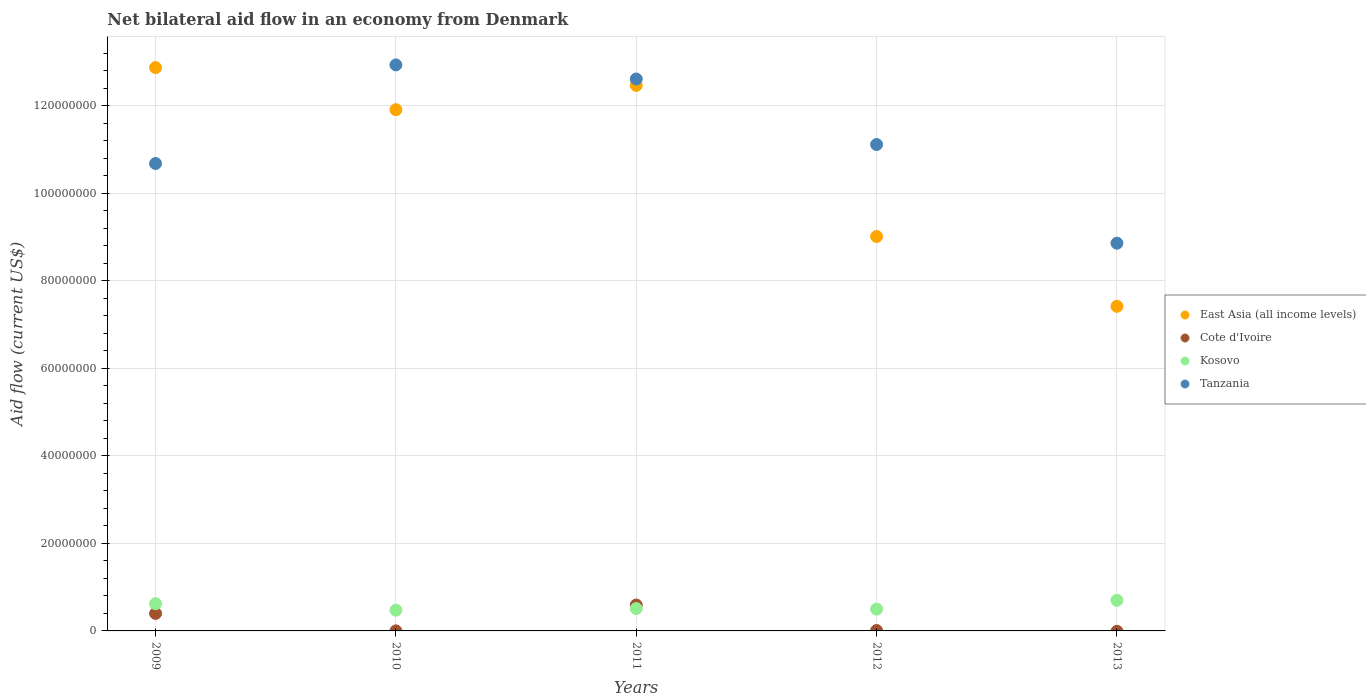Is the number of dotlines equal to the number of legend labels?
Your response must be concise. No. What is the net bilateral aid flow in Tanzania in 2009?
Ensure brevity in your answer.  1.07e+08. Across all years, what is the maximum net bilateral aid flow in East Asia (all income levels)?
Keep it short and to the point. 1.29e+08. Across all years, what is the minimum net bilateral aid flow in Tanzania?
Offer a terse response. 8.86e+07. What is the total net bilateral aid flow in Kosovo in the graph?
Provide a short and direct response. 2.81e+07. What is the difference between the net bilateral aid flow in Kosovo in 2010 and that in 2013?
Provide a succinct answer. -2.26e+06. What is the difference between the net bilateral aid flow in East Asia (all income levels) in 2011 and the net bilateral aid flow in Kosovo in 2010?
Keep it short and to the point. 1.20e+08. What is the average net bilateral aid flow in Kosovo per year?
Give a very brief answer. 5.61e+06. In the year 2010, what is the difference between the net bilateral aid flow in Kosovo and net bilateral aid flow in Tanzania?
Provide a succinct answer. -1.25e+08. In how many years, is the net bilateral aid flow in East Asia (all income levels) greater than 32000000 US$?
Your answer should be very brief. 5. What is the ratio of the net bilateral aid flow in Tanzania in 2010 to that in 2013?
Offer a terse response. 1.46. What is the difference between the highest and the second highest net bilateral aid flow in East Asia (all income levels)?
Ensure brevity in your answer.  4.06e+06. What is the difference between the highest and the lowest net bilateral aid flow in East Asia (all income levels)?
Offer a terse response. 5.46e+07. In how many years, is the net bilateral aid flow in East Asia (all income levels) greater than the average net bilateral aid flow in East Asia (all income levels) taken over all years?
Offer a terse response. 3. Is the sum of the net bilateral aid flow in Kosovo in 2011 and 2013 greater than the maximum net bilateral aid flow in Cote d'Ivoire across all years?
Your answer should be compact. Yes. Is it the case that in every year, the sum of the net bilateral aid flow in Kosovo and net bilateral aid flow in Tanzania  is greater than the net bilateral aid flow in East Asia (all income levels)?
Give a very brief answer. No. Is the net bilateral aid flow in Kosovo strictly less than the net bilateral aid flow in Cote d'Ivoire over the years?
Keep it short and to the point. No. How many dotlines are there?
Your response must be concise. 4. What is the difference between two consecutive major ticks on the Y-axis?
Ensure brevity in your answer.  2.00e+07. Are the values on the major ticks of Y-axis written in scientific E-notation?
Provide a succinct answer. No. Where does the legend appear in the graph?
Your answer should be compact. Center right. How many legend labels are there?
Keep it short and to the point. 4. How are the legend labels stacked?
Your answer should be very brief. Vertical. What is the title of the graph?
Provide a succinct answer. Net bilateral aid flow in an economy from Denmark. What is the label or title of the X-axis?
Provide a short and direct response. Years. What is the label or title of the Y-axis?
Make the answer very short. Aid flow (current US$). What is the Aid flow (current US$) in East Asia (all income levels) in 2009?
Your answer should be very brief. 1.29e+08. What is the Aid flow (current US$) in Kosovo in 2009?
Provide a succinct answer. 6.22e+06. What is the Aid flow (current US$) in Tanzania in 2009?
Ensure brevity in your answer.  1.07e+08. What is the Aid flow (current US$) of East Asia (all income levels) in 2010?
Make the answer very short. 1.19e+08. What is the Aid flow (current US$) in Kosovo in 2010?
Provide a short and direct response. 4.74e+06. What is the Aid flow (current US$) in Tanzania in 2010?
Your answer should be compact. 1.29e+08. What is the Aid flow (current US$) of East Asia (all income levels) in 2011?
Provide a short and direct response. 1.25e+08. What is the Aid flow (current US$) in Cote d'Ivoire in 2011?
Give a very brief answer. 5.92e+06. What is the Aid flow (current US$) of Kosovo in 2011?
Offer a terse response. 5.12e+06. What is the Aid flow (current US$) of Tanzania in 2011?
Ensure brevity in your answer.  1.26e+08. What is the Aid flow (current US$) in East Asia (all income levels) in 2012?
Provide a short and direct response. 9.02e+07. What is the Aid flow (current US$) in Cote d'Ivoire in 2012?
Your answer should be very brief. 9.00e+04. What is the Aid flow (current US$) in Kosovo in 2012?
Offer a very short reply. 4.99e+06. What is the Aid flow (current US$) in Tanzania in 2012?
Offer a very short reply. 1.11e+08. What is the Aid flow (current US$) in East Asia (all income levels) in 2013?
Your answer should be compact. 7.42e+07. What is the Aid flow (current US$) in Cote d'Ivoire in 2013?
Keep it short and to the point. 0. What is the Aid flow (current US$) in Tanzania in 2013?
Keep it short and to the point. 8.86e+07. Across all years, what is the maximum Aid flow (current US$) in East Asia (all income levels)?
Provide a succinct answer. 1.29e+08. Across all years, what is the maximum Aid flow (current US$) of Cote d'Ivoire?
Provide a succinct answer. 5.92e+06. Across all years, what is the maximum Aid flow (current US$) of Kosovo?
Give a very brief answer. 7.00e+06. Across all years, what is the maximum Aid flow (current US$) in Tanzania?
Ensure brevity in your answer.  1.29e+08. Across all years, what is the minimum Aid flow (current US$) of East Asia (all income levels)?
Make the answer very short. 7.42e+07. Across all years, what is the minimum Aid flow (current US$) in Kosovo?
Offer a terse response. 4.74e+06. Across all years, what is the minimum Aid flow (current US$) of Tanzania?
Make the answer very short. 8.86e+07. What is the total Aid flow (current US$) in East Asia (all income levels) in the graph?
Offer a very short reply. 5.37e+08. What is the total Aid flow (current US$) in Cote d'Ivoire in the graph?
Offer a terse response. 1.00e+07. What is the total Aid flow (current US$) in Kosovo in the graph?
Keep it short and to the point. 2.81e+07. What is the total Aid flow (current US$) of Tanzania in the graph?
Provide a short and direct response. 5.62e+08. What is the difference between the Aid flow (current US$) in East Asia (all income levels) in 2009 and that in 2010?
Offer a terse response. 9.62e+06. What is the difference between the Aid flow (current US$) of Cote d'Ivoire in 2009 and that in 2010?
Ensure brevity in your answer.  3.99e+06. What is the difference between the Aid flow (current US$) in Kosovo in 2009 and that in 2010?
Provide a short and direct response. 1.48e+06. What is the difference between the Aid flow (current US$) of Tanzania in 2009 and that in 2010?
Provide a succinct answer. -2.25e+07. What is the difference between the Aid flow (current US$) of East Asia (all income levels) in 2009 and that in 2011?
Ensure brevity in your answer.  4.06e+06. What is the difference between the Aid flow (current US$) of Cote d'Ivoire in 2009 and that in 2011?
Offer a very short reply. -1.92e+06. What is the difference between the Aid flow (current US$) of Kosovo in 2009 and that in 2011?
Offer a terse response. 1.10e+06. What is the difference between the Aid flow (current US$) in Tanzania in 2009 and that in 2011?
Your response must be concise. -1.93e+07. What is the difference between the Aid flow (current US$) in East Asia (all income levels) in 2009 and that in 2012?
Offer a very short reply. 3.86e+07. What is the difference between the Aid flow (current US$) in Cote d'Ivoire in 2009 and that in 2012?
Keep it short and to the point. 3.91e+06. What is the difference between the Aid flow (current US$) in Kosovo in 2009 and that in 2012?
Your response must be concise. 1.23e+06. What is the difference between the Aid flow (current US$) in Tanzania in 2009 and that in 2012?
Your answer should be very brief. -4.34e+06. What is the difference between the Aid flow (current US$) of East Asia (all income levels) in 2009 and that in 2013?
Provide a succinct answer. 5.46e+07. What is the difference between the Aid flow (current US$) of Kosovo in 2009 and that in 2013?
Provide a short and direct response. -7.80e+05. What is the difference between the Aid flow (current US$) of Tanzania in 2009 and that in 2013?
Your answer should be very brief. 1.82e+07. What is the difference between the Aid flow (current US$) of East Asia (all income levels) in 2010 and that in 2011?
Provide a short and direct response. -5.56e+06. What is the difference between the Aid flow (current US$) in Cote d'Ivoire in 2010 and that in 2011?
Ensure brevity in your answer.  -5.91e+06. What is the difference between the Aid flow (current US$) of Kosovo in 2010 and that in 2011?
Keep it short and to the point. -3.80e+05. What is the difference between the Aid flow (current US$) in Tanzania in 2010 and that in 2011?
Offer a terse response. 3.23e+06. What is the difference between the Aid flow (current US$) in East Asia (all income levels) in 2010 and that in 2012?
Offer a terse response. 2.90e+07. What is the difference between the Aid flow (current US$) of Cote d'Ivoire in 2010 and that in 2012?
Ensure brevity in your answer.  -8.00e+04. What is the difference between the Aid flow (current US$) in Tanzania in 2010 and that in 2012?
Keep it short and to the point. 1.82e+07. What is the difference between the Aid flow (current US$) of East Asia (all income levels) in 2010 and that in 2013?
Your answer should be compact. 4.50e+07. What is the difference between the Aid flow (current US$) in Kosovo in 2010 and that in 2013?
Provide a succinct answer. -2.26e+06. What is the difference between the Aid flow (current US$) in Tanzania in 2010 and that in 2013?
Your answer should be compact. 4.08e+07. What is the difference between the Aid flow (current US$) in East Asia (all income levels) in 2011 and that in 2012?
Your answer should be very brief. 3.46e+07. What is the difference between the Aid flow (current US$) of Cote d'Ivoire in 2011 and that in 2012?
Your answer should be compact. 5.83e+06. What is the difference between the Aid flow (current US$) in Tanzania in 2011 and that in 2012?
Offer a very short reply. 1.50e+07. What is the difference between the Aid flow (current US$) in East Asia (all income levels) in 2011 and that in 2013?
Offer a terse response. 5.05e+07. What is the difference between the Aid flow (current US$) in Kosovo in 2011 and that in 2013?
Your response must be concise. -1.88e+06. What is the difference between the Aid flow (current US$) in Tanzania in 2011 and that in 2013?
Make the answer very short. 3.75e+07. What is the difference between the Aid flow (current US$) of East Asia (all income levels) in 2012 and that in 2013?
Offer a very short reply. 1.60e+07. What is the difference between the Aid flow (current US$) in Kosovo in 2012 and that in 2013?
Give a very brief answer. -2.01e+06. What is the difference between the Aid flow (current US$) of Tanzania in 2012 and that in 2013?
Give a very brief answer. 2.26e+07. What is the difference between the Aid flow (current US$) of East Asia (all income levels) in 2009 and the Aid flow (current US$) of Cote d'Ivoire in 2010?
Your response must be concise. 1.29e+08. What is the difference between the Aid flow (current US$) of East Asia (all income levels) in 2009 and the Aid flow (current US$) of Kosovo in 2010?
Ensure brevity in your answer.  1.24e+08. What is the difference between the Aid flow (current US$) in East Asia (all income levels) in 2009 and the Aid flow (current US$) in Tanzania in 2010?
Provide a succinct answer. -6.20e+05. What is the difference between the Aid flow (current US$) of Cote d'Ivoire in 2009 and the Aid flow (current US$) of Kosovo in 2010?
Keep it short and to the point. -7.40e+05. What is the difference between the Aid flow (current US$) in Cote d'Ivoire in 2009 and the Aid flow (current US$) in Tanzania in 2010?
Offer a terse response. -1.25e+08. What is the difference between the Aid flow (current US$) in Kosovo in 2009 and the Aid flow (current US$) in Tanzania in 2010?
Keep it short and to the point. -1.23e+08. What is the difference between the Aid flow (current US$) in East Asia (all income levels) in 2009 and the Aid flow (current US$) in Cote d'Ivoire in 2011?
Make the answer very short. 1.23e+08. What is the difference between the Aid flow (current US$) in East Asia (all income levels) in 2009 and the Aid flow (current US$) in Kosovo in 2011?
Keep it short and to the point. 1.24e+08. What is the difference between the Aid flow (current US$) in East Asia (all income levels) in 2009 and the Aid flow (current US$) in Tanzania in 2011?
Your answer should be compact. 2.61e+06. What is the difference between the Aid flow (current US$) of Cote d'Ivoire in 2009 and the Aid flow (current US$) of Kosovo in 2011?
Provide a succinct answer. -1.12e+06. What is the difference between the Aid flow (current US$) in Cote d'Ivoire in 2009 and the Aid flow (current US$) in Tanzania in 2011?
Offer a terse response. -1.22e+08. What is the difference between the Aid flow (current US$) of Kosovo in 2009 and the Aid flow (current US$) of Tanzania in 2011?
Keep it short and to the point. -1.20e+08. What is the difference between the Aid flow (current US$) of East Asia (all income levels) in 2009 and the Aid flow (current US$) of Cote d'Ivoire in 2012?
Give a very brief answer. 1.29e+08. What is the difference between the Aid flow (current US$) of East Asia (all income levels) in 2009 and the Aid flow (current US$) of Kosovo in 2012?
Your response must be concise. 1.24e+08. What is the difference between the Aid flow (current US$) in East Asia (all income levels) in 2009 and the Aid flow (current US$) in Tanzania in 2012?
Keep it short and to the point. 1.76e+07. What is the difference between the Aid flow (current US$) of Cote d'Ivoire in 2009 and the Aid flow (current US$) of Kosovo in 2012?
Offer a terse response. -9.90e+05. What is the difference between the Aid flow (current US$) of Cote d'Ivoire in 2009 and the Aid flow (current US$) of Tanzania in 2012?
Make the answer very short. -1.07e+08. What is the difference between the Aid flow (current US$) of Kosovo in 2009 and the Aid flow (current US$) of Tanzania in 2012?
Ensure brevity in your answer.  -1.05e+08. What is the difference between the Aid flow (current US$) in East Asia (all income levels) in 2009 and the Aid flow (current US$) in Kosovo in 2013?
Make the answer very short. 1.22e+08. What is the difference between the Aid flow (current US$) of East Asia (all income levels) in 2009 and the Aid flow (current US$) of Tanzania in 2013?
Provide a short and direct response. 4.01e+07. What is the difference between the Aid flow (current US$) of Cote d'Ivoire in 2009 and the Aid flow (current US$) of Kosovo in 2013?
Your response must be concise. -3.00e+06. What is the difference between the Aid flow (current US$) of Cote d'Ivoire in 2009 and the Aid flow (current US$) of Tanzania in 2013?
Your answer should be compact. -8.46e+07. What is the difference between the Aid flow (current US$) in Kosovo in 2009 and the Aid flow (current US$) in Tanzania in 2013?
Give a very brief answer. -8.24e+07. What is the difference between the Aid flow (current US$) in East Asia (all income levels) in 2010 and the Aid flow (current US$) in Cote d'Ivoire in 2011?
Keep it short and to the point. 1.13e+08. What is the difference between the Aid flow (current US$) of East Asia (all income levels) in 2010 and the Aid flow (current US$) of Kosovo in 2011?
Provide a succinct answer. 1.14e+08. What is the difference between the Aid flow (current US$) in East Asia (all income levels) in 2010 and the Aid flow (current US$) in Tanzania in 2011?
Your answer should be compact. -7.01e+06. What is the difference between the Aid flow (current US$) in Cote d'Ivoire in 2010 and the Aid flow (current US$) in Kosovo in 2011?
Your answer should be compact. -5.11e+06. What is the difference between the Aid flow (current US$) of Cote d'Ivoire in 2010 and the Aid flow (current US$) of Tanzania in 2011?
Provide a short and direct response. -1.26e+08. What is the difference between the Aid flow (current US$) in Kosovo in 2010 and the Aid flow (current US$) in Tanzania in 2011?
Offer a terse response. -1.21e+08. What is the difference between the Aid flow (current US$) of East Asia (all income levels) in 2010 and the Aid flow (current US$) of Cote d'Ivoire in 2012?
Offer a terse response. 1.19e+08. What is the difference between the Aid flow (current US$) in East Asia (all income levels) in 2010 and the Aid flow (current US$) in Kosovo in 2012?
Offer a very short reply. 1.14e+08. What is the difference between the Aid flow (current US$) of East Asia (all income levels) in 2010 and the Aid flow (current US$) of Tanzania in 2012?
Make the answer very short. 7.96e+06. What is the difference between the Aid flow (current US$) in Cote d'Ivoire in 2010 and the Aid flow (current US$) in Kosovo in 2012?
Make the answer very short. -4.98e+06. What is the difference between the Aid flow (current US$) in Cote d'Ivoire in 2010 and the Aid flow (current US$) in Tanzania in 2012?
Your answer should be very brief. -1.11e+08. What is the difference between the Aid flow (current US$) of Kosovo in 2010 and the Aid flow (current US$) of Tanzania in 2012?
Keep it short and to the point. -1.06e+08. What is the difference between the Aid flow (current US$) of East Asia (all income levels) in 2010 and the Aid flow (current US$) of Kosovo in 2013?
Offer a very short reply. 1.12e+08. What is the difference between the Aid flow (current US$) of East Asia (all income levels) in 2010 and the Aid flow (current US$) of Tanzania in 2013?
Provide a succinct answer. 3.05e+07. What is the difference between the Aid flow (current US$) in Cote d'Ivoire in 2010 and the Aid flow (current US$) in Kosovo in 2013?
Ensure brevity in your answer.  -6.99e+06. What is the difference between the Aid flow (current US$) in Cote d'Ivoire in 2010 and the Aid flow (current US$) in Tanzania in 2013?
Your response must be concise. -8.86e+07. What is the difference between the Aid flow (current US$) of Kosovo in 2010 and the Aid flow (current US$) of Tanzania in 2013?
Offer a very short reply. -8.39e+07. What is the difference between the Aid flow (current US$) of East Asia (all income levels) in 2011 and the Aid flow (current US$) of Cote d'Ivoire in 2012?
Provide a succinct answer. 1.25e+08. What is the difference between the Aid flow (current US$) in East Asia (all income levels) in 2011 and the Aid flow (current US$) in Kosovo in 2012?
Offer a terse response. 1.20e+08. What is the difference between the Aid flow (current US$) in East Asia (all income levels) in 2011 and the Aid flow (current US$) in Tanzania in 2012?
Make the answer very short. 1.35e+07. What is the difference between the Aid flow (current US$) of Cote d'Ivoire in 2011 and the Aid flow (current US$) of Kosovo in 2012?
Offer a terse response. 9.30e+05. What is the difference between the Aid flow (current US$) of Cote d'Ivoire in 2011 and the Aid flow (current US$) of Tanzania in 2012?
Offer a terse response. -1.05e+08. What is the difference between the Aid flow (current US$) of Kosovo in 2011 and the Aid flow (current US$) of Tanzania in 2012?
Your response must be concise. -1.06e+08. What is the difference between the Aid flow (current US$) of East Asia (all income levels) in 2011 and the Aid flow (current US$) of Kosovo in 2013?
Your answer should be very brief. 1.18e+08. What is the difference between the Aid flow (current US$) of East Asia (all income levels) in 2011 and the Aid flow (current US$) of Tanzania in 2013?
Your answer should be very brief. 3.61e+07. What is the difference between the Aid flow (current US$) in Cote d'Ivoire in 2011 and the Aid flow (current US$) in Kosovo in 2013?
Your answer should be very brief. -1.08e+06. What is the difference between the Aid flow (current US$) in Cote d'Ivoire in 2011 and the Aid flow (current US$) in Tanzania in 2013?
Provide a succinct answer. -8.27e+07. What is the difference between the Aid flow (current US$) in Kosovo in 2011 and the Aid flow (current US$) in Tanzania in 2013?
Make the answer very short. -8.35e+07. What is the difference between the Aid flow (current US$) in East Asia (all income levels) in 2012 and the Aid flow (current US$) in Kosovo in 2013?
Offer a very short reply. 8.32e+07. What is the difference between the Aid flow (current US$) of East Asia (all income levels) in 2012 and the Aid flow (current US$) of Tanzania in 2013?
Give a very brief answer. 1.53e+06. What is the difference between the Aid flow (current US$) in Cote d'Ivoire in 2012 and the Aid flow (current US$) in Kosovo in 2013?
Your response must be concise. -6.91e+06. What is the difference between the Aid flow (current US$) in Cote d'Ivoire in 2012 and the Aid flow (current US$) in Tanzania in 2013?
Your answer should be very brief. -8.85e+07. What is the difference between the Aid flow (current US$) in Kosovo in 2012 and the Aid flow (current US$) in Tanzania in 2013?
Your response must be concise. -8.36e+07. What is the average Aid flow (current US$) of East Asia (all income levels) per year?
Provide a short and direct response. 1.07e+08. What is the average Aid flow (current US$) of Cote d'Ivoire per year?
Your answer should be very brief. 2.00e+06. What is the average Aid flow (current US$) of Kosovo per year?
Offer a very short reply. 5.61e+06. What is the average Aid flow (current US$) of Tanzania per year?
Provide a succinct answer. 1.12e+08. In the year 2009, what is the difference between the Aid flow (current US$) of East Asia (all income levels) and Aid flow (current US$) of Cote d'Ivoire?
Keep it short and to the point. 1.25e+08. In the year 2009, what is the difference between the Aid flow (current US$) in East Asia (all income levels) and Aid flow (current US$) in Kosovo?
Offer a very short reply. 1.23e+08. In the year 2009, what is the difference between the Aid flow (current US$) in East Asia (all income levels) and Aid flow (current US$) in Tanzania?
Your response must be concise. 2.19e+07. In the year 2009, what is the difference between the Aid flow (current US$) of Cote d'Ivoire and Aid flow (current US$) of Kosovo?
Offer a terse response. -2.22e+06. In the year 2009, what is the difference between the Aid flow (current US$) in Cote d'Ivoire and Aid flow (current US$) in Tanzania?
Your answer should be compact. -1.03e+08. In the year 2009, what is the difference between the Aid flow (current US$) in Kosovo and Aid flow (current US$) in Tanzania?
Offer a terse response. -1.01e+08. In the year 2010, what is the difference between the Aid flow (current US$) of East Asia (all income levels) and Aid flow (current US$) of Cote d'Ivoire?
Your answer should be very brief. 1.19e+08. In the year 2010, what is the difference between the Aid flow (current US$) of East Asia (all income levels) and Aid flow (current US$) of Kosovo?
Make the answer very short. 1.14e+08. In the year 2010, what is the difference between the Aid flow (current US$) of East Asia (all income levels) and Aid flow (current US$) of Tanzania?
Give a very brief answer. -1.02e+07. In the year 2010, what is the difference between the Aid flow (current US$) of Cote d'Ivoire and Aid flow (current US$) of Kosovo?
Your response must be concise. -4.73e+06. In the year 2010, what is the difference between the Aid flow (current US$) in Cote d'Ivoire and Aid flow (current US$) in Tanzania?
Ensure brevity in your answer.  -1.29e+08. In the year 2010, what is the difference between the Aid flow (current US$) of Kosovo and Aid flow (current US$) of Tanzania?
Provide a succinct answer. -1.25e+08. In the year 2011, what is the difference between the Aid flow (current US$) of East Asia (all income levels) and Aid flow (current US$) of Cote d'Ivoire?
Offer a terse response. 1.19e+08. In the year 2011, what is the difference between the Aid flow (current US$) of East Asia (all income levels) and Aid flow (current US$) of Kosovo?
Ensure brevity in your answer.  1.20e+08. In the year 2011, what is the difference between the Aid flow (current US$) of East Asia (all income levels) and Aid flow (current US$) of Tanzania?
Provide a short and direct response. -1.45e+06. In the year 2011, what is the difference between the Aid flow (current US$) of Cote d'Ivoire and Aid flow (current US$) of Tanzania?
Your answer should be very brief. -1.20e+08. In the year 2011, what is the difference between the Aid flow (current US$) in Kosovo and Aid flow (current US$) in Tanzania?
Offer a very short reply. -1.21e+08. In the year 2012, what is the difference between the Aid flow (current US$) of East Asia (all income levels) and Aid flow (current US$) of Cote d'Ivoire?
Your answer should be compact. 9.01e+07. In the year 2012, what is the difference between the Aid flow (current US$) in East Asia (all income levels) and Aid flow (current US$) in Kosovo?
Offer a very short reply. 8.52e+07. In the year 2012, what is the difference between the Aid flow (current US$) of East Asia (all income levels) and Aid flow (current US$) of Tanzania?
Ensure brevity in your answer.  -2.10e+07. In the year 2012, what is the difference between the Aid flow (current US$) of Cote d'Ivoire and Aid flow (current US$) of Kosovo?
Provide a short and direct response. -4.90e+06. In the year 2012, what is the difference between the Aid flow (current US$) in Cote d'Ivoire and Aid flow (current US$) in Tanzania?
Make the answer very short. -1.11e+08. In the year 2012, what is the difference between the Aid flow (current US$) in Kosovo and Aid flow (current US$) in Tanzania?
Keep it short and to the point. -1.06e+08. In the year 2013, what is the difference between the Aid flow (current US$) of East Asia (all income levels) and Aid flow (current US$) of Kosovo?
Make the answer very short. 6.72e+07. In the year 2013, what is the difference between the Aid flow (current US$) of East Asia (all income levels) and Aid flow (current US$) of Tanzania?
Provide a succinct answer. -1.44e+07. In the year 2013, what is the difference between the Aid flow (current US$) of Kosovo and Aid flow (current US$) of Tanzania?
Offer a very short reply. -8.16e+07. What is the ratio of the Aid flow (current US$) of East Asia (all income levels) in 2009 to that in 2010?
Provide a short and direct response. 1.08. What is the ratio of the Aid flow (current US$) in Kosovo in 2009 to that in 2010?
Provide a short and direct response. 1.31. What is the ratio of the Aid flow (current US$) of Tanzania in 2009 to that in 2010?
Your response must be concise. 0.83. What is the ratio of the Aid flow (current US$) in East Asia (all income levels) in 2009 to that in 2011?
Ensure brevity in your answer.  1.03. What is the ratio of the Aid flow (current US$) in Cote d'Ivoire in 2009 to that in 2011?
Give a very brief answer. 0.68. What is the ratio of the Aid flow (current US$) of Kosovo in 2009 to that in 2011?
Make the answer very short. 1.21. What is the ratio of the Aid flow (current US$) in Tanzania in 2009 to that in 2011?
Give a very brief answer. 0.85. What is the ratio of the Aid flow (current US$) in East Asia (all income levels) in 2009 to that in 2012?
Provide a succinct answer. 1.43. What is the ratio of the Aid flow (current US$) in Cote d'Ivoire in 2009 to that in 2012?
Make the answer very short. 44.44. What is the ratio of the Aid flow (current US$) in Kosovo in 2009 to that in 2012?
Your response must be concise. 1.25. What is the ratio of the Aid flow (current US$) of East Asia (all income levels) in 2009 to that in 2013?
Ensure brevity in your answer.  1.74. What is the ratio of the Aid flow (current US$) in Kosovo in 2009 to that in 2013?
Keep it short and to the point. 0.89. What is the ratio of the Aid flow (current US$) in Tanzania in 2009 to that in 2013?
Provide a succinct answer. 1.21. What is the ratio of the Aid flow (current US$) in East Asia (all income levels) in 2010 to that in 2011?
Provide a succinct answer. 0.96. What is the ratio of the Aid flow (current US$) in Cote d'Ivoire in 2010 to that in 2011?
Your answer should be compact. 0. What is the ratio of the Aid flow (current US$) in Kosovo in 2010 to that in 2011?
Provide a succinct answer. 0.93. What is the ratio of the Aid flow (current US$) in Tanzania in 2010 to that in 2011?
Your response must be concise. 1.03. What is the ratio of the Aid flow (current US$) of East Asia (all income levels) in 2010 to that in 2012?
Give a very brief answer. 1.32. What is the ratio of the Aid flow (current US$) in Cote d'Ivoire in 2010 to that in 2012?
Offer a terse response. 0.11. What is the ratio of the Aid flow (current US$) of Kosovo in 2010 to that in 2012?
Keep it short and to the point. 0.95. What is the ratio of the Aid flow (current US$) of Tanzania in 2010 to that in 2012?
Keep it short and to the point. 1.16. What is the ratio of the Aid flow (current US$) of East Asia (all income levels) in 2010 to that in 2013?
Provide a short and direct response. 1.61. What is the ratio of the Aid flow (current US$) of Kosovo in 2010 to that in 2013?
Give a very brief answer. 0.68. What is the ratio of the Aid flow (current US$) of Tanzania in 2010 to that in 2013?
Offer a very short reply. 1.46. What is the ratio of the Aid flow (current US$) of East Asia (all income levels) in 2011 to that in 2012?
Ensure brevity in your answer.  1.38. What is the ratio of the Aid flow (current US$) of Cote d'Ivoire in 2011 to that in 2012?
Offer a terse response. 65.78. What is the ratio of the Aid flow (current US$) in Kosovo in 2011 to that in 2012?
Your answer should be very brief. 1.03. What is the ratio of the Aid flow (current US$) of Tanzania in 2011 to that in 2012?
Give a very brief answer. 1.13. What is the ratio of the Aid flow (current US$) in East Asia (all income levels) in 2011 to that in 2013?
Provide a succinct answer. 1.68. What is the ratio of the Aid flow (current US$) in Kosovo in 2011 to that in 2013?
Ensure brevity in your answer.  0.73. What is the ratio of the Aid flow (current US$) in Tanzania in 2011 to that in 2013?
Give a very brief answer. 1.42. What is the ratio of the Aid flow (current US$) of East Asia (all income levels) in 2012 to that in 2013?
Your answer should be very brief. 1.22. What is the ratio of the Aid flow (current US$) in Kosovo in 2012 to that in 2013?
Provide a short and direct response. 0.71. What is the ratio of the Aid flow (current US$) of Tanzania in 2012 to that in 2013?
Your answer should be compact. 1.25. What is the difference between the highest and the second highest Aid flow (current US$) in East Asia (all income levels)?
Your response must be concise. 4.06e+06. What is the difference between the highest and the second highest Aid flow (current US$) of Cote d'Ivoire?
Your response must be concise. 1.92e+06. What is the difference between the highest and the second highest Aid flow (current US$) in Kosovo?
Keep it short and to the point. 7.80e+05. What is the difference between the highest and the second highest Aid flow (current US$) of Tanzania?
Make the answer very short. 3.23e+06. What is the difference between the highest and the lowest Aid flow (current US$) of East Asia (all income levels)?
Provide a short and direct response. 5.46e+07. What is the difference between the highest and the lowest Aid flow (current US$) in Cote d'Ivoire?
Ensure brevity in your answer.  5.92e+06. What is the difference between the highest and the lowest Aid flow (current US$) in Kosovo?
Make the answer very short. 2.26e+06. What is the difference between the highest and the lowest Aid flow (current US$) in Tanzania?
Make the answer very short. 4.08e+07. 